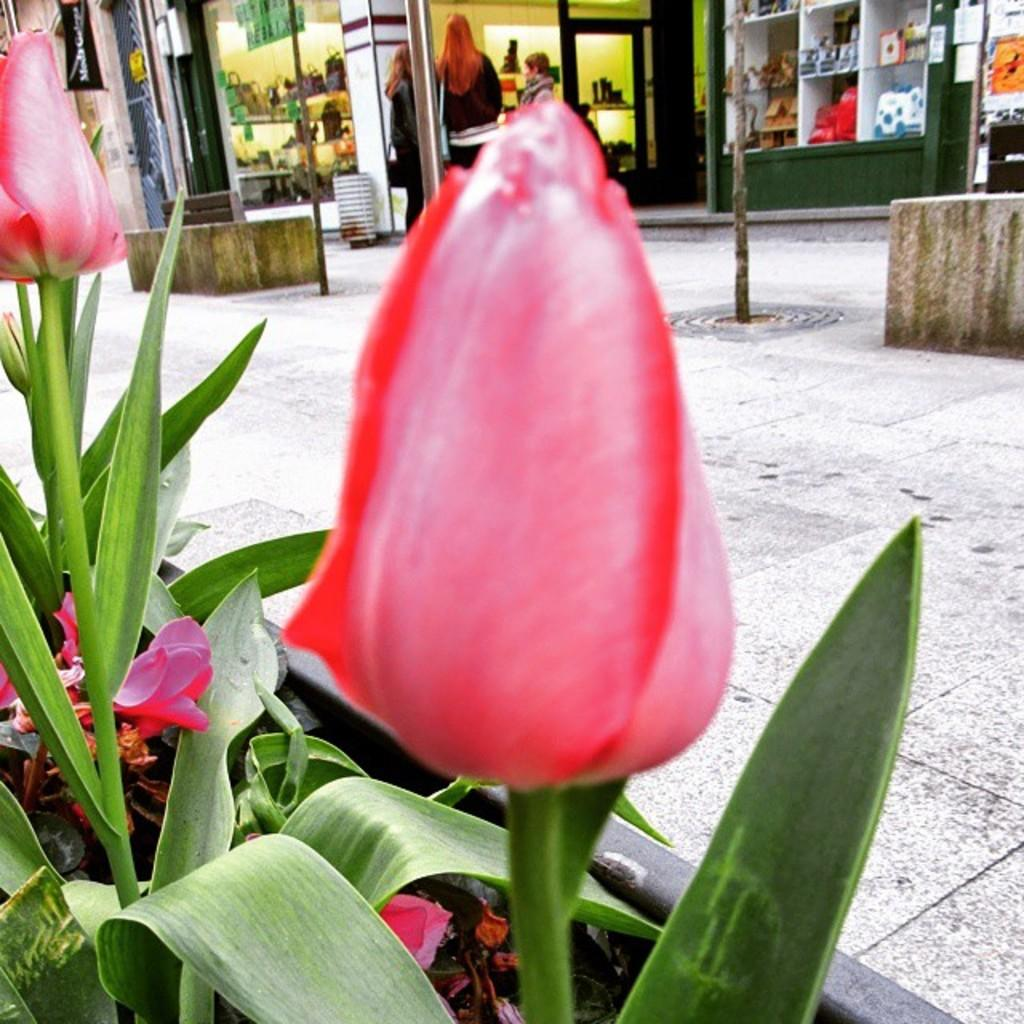What type of plant is visible in the image? There is a flower plant in the image. What can be seen behind the pavement in the image? There are stores behind the pavement in the image. What is happening in front of the stores in the image? There are people standing in front of the stores. What flavor of ice cream is being sold in the stores in the image? There is no mention of ice cream or any specific flavors in the image. What invention is being used by the people standing in front of the stores in the image? There is no specific invention visible in the image; people are simply standing in front of the stores. 